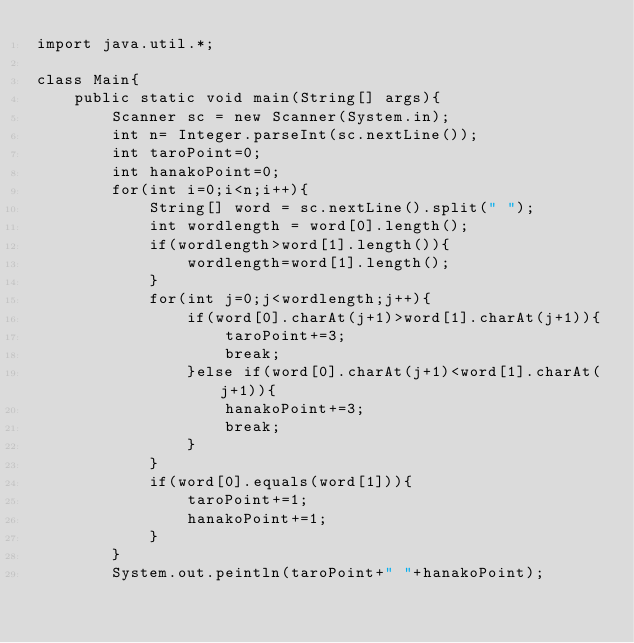<code> <loc_0><loc_0><loc_500><loc_500><_Java_>import java.util.*;

class Main{
	public static void main(String[] args){
		Scanner sc = new Scanner(System.in);
		int n= Integer.parseInt(sc.nextLine());
		int taroPoint=0;
		int hanakoPoint=0;
		for(int i=0;i<n;i++){
			String[] word = sc.nextLine().split(" ");
			int wordlength = word[0].length();
			if(wordlength>word[1].length()){
				wordlength=word[1].length();
			}
			for(int j=0;j<wordlength;j++){
				if(word[0].charAt(j+1)>word[1].charAt(j+1)){
					taroPoint+=3;
					break;
				}else if(word[0].charAt(j+1)<word[1].charAt(j+1)){
					hanakoPoint+=3;
					break;
				}
			}
			if(word[0].equals(word[1])){
				taroPoint+=1;
				hanakoPoint+=1;
			}
		}
		System.out.peintln(taroPoint+" "+hanakoPoint);</code> 